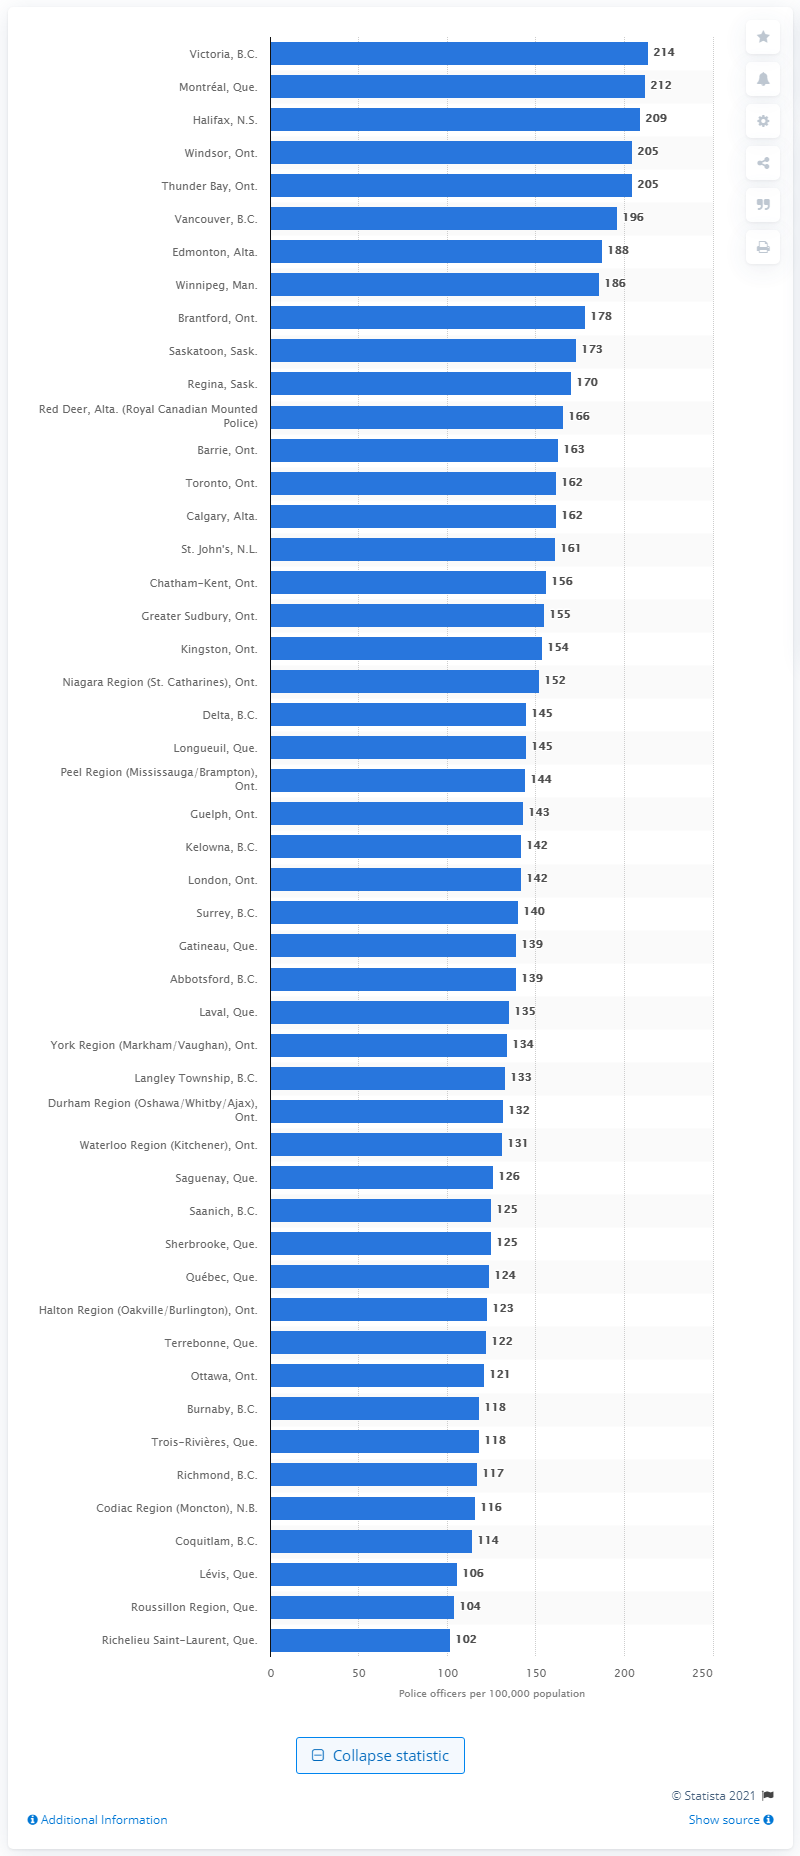Point out several critical features in this image. In 2019, there were 212 police officers serving in Montral. 